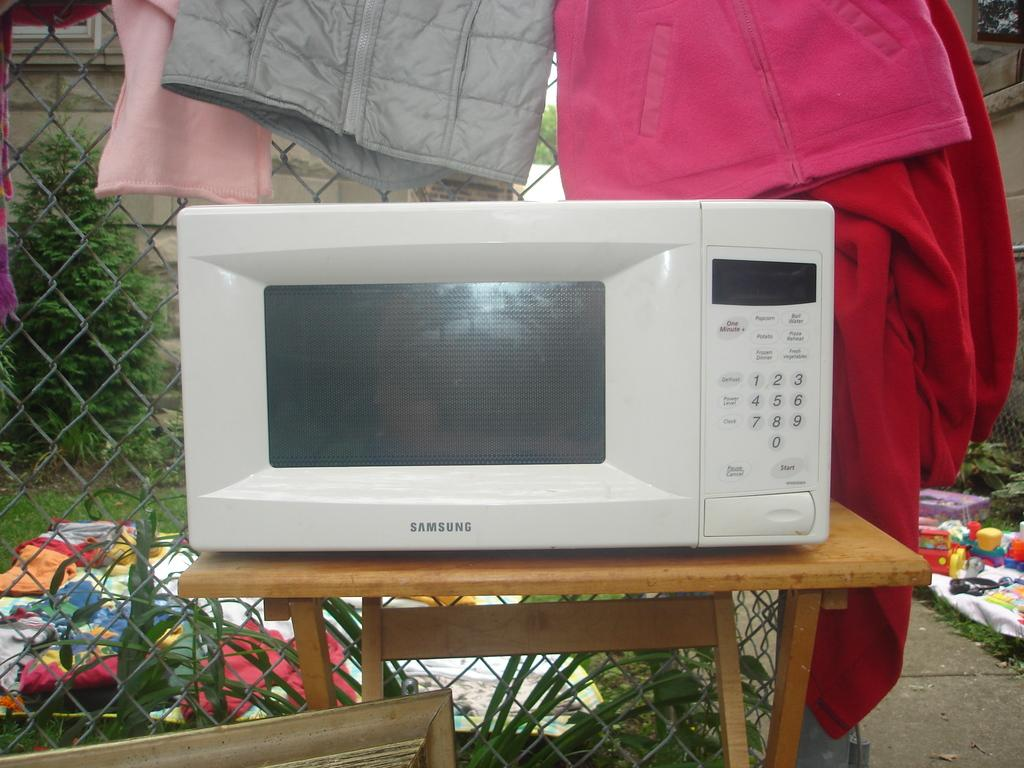<image>
Offer a succinct explanation of the picture presented. a microwave that was made from Samsung and is white 